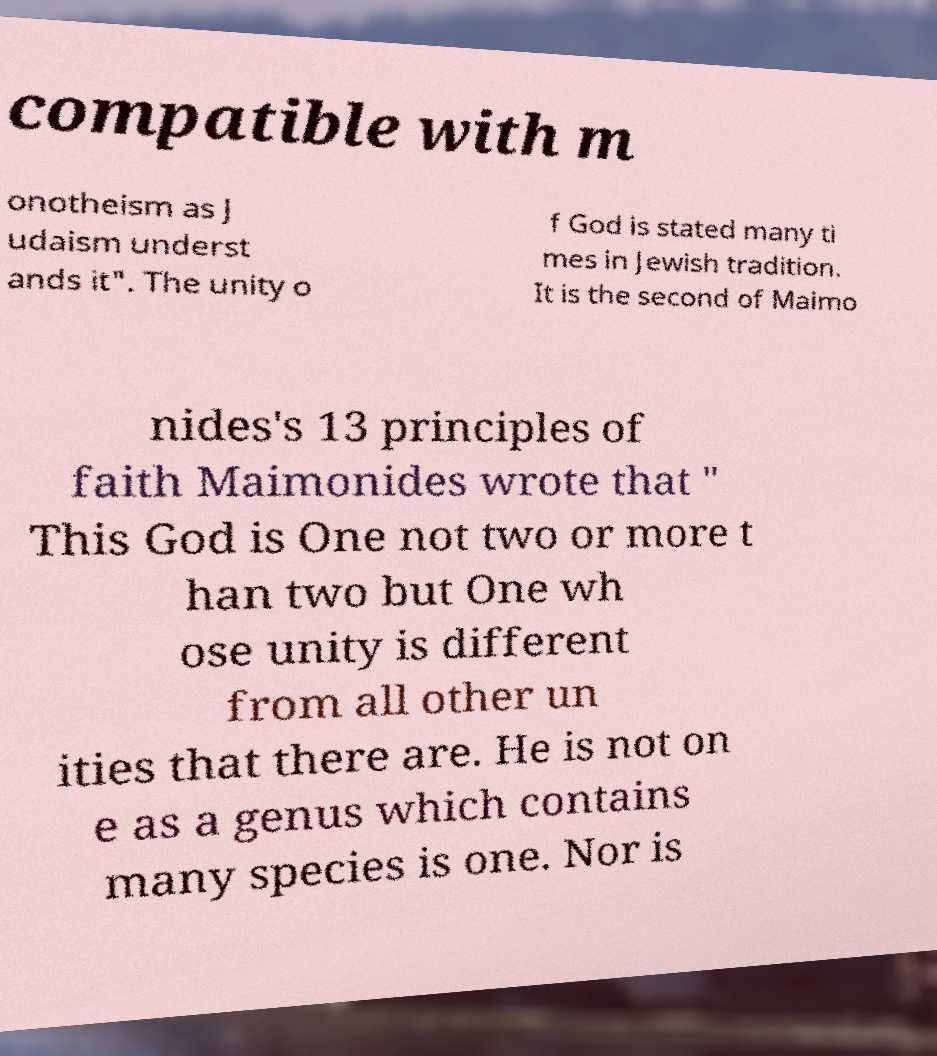I need the written content from this picture converted into text. Can you do that? compatible with m onotheism as J udaism underst ands it". The unity o f God is stated many ti mes in Jewish tradition. It is the second of Maimo nides's 13 principles of faith Maimonides wrote that " This God is One not two or more t han two but One wh ose unity is different from all other un ities that there are. He is not on e as a genus which contains many species is one. Nor is 